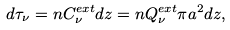Convert formula to latex. <formula><loc_0><loc_0><loc_500><loc_500>d \tau _ { \nu } = n C ^ { e x t } _ { \nu } d z = n Q ^ { e x t } _ { \nu } \pi a ^ { 2 } d z ,</formula> 